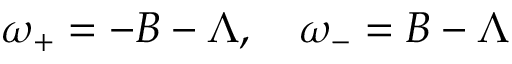<formula> <loc_0><loc_0><loc_500><loc_500>\omega _ { + } = - B - \Lambda , \quad \omega _ { - } = B - \Lambda</formula> 